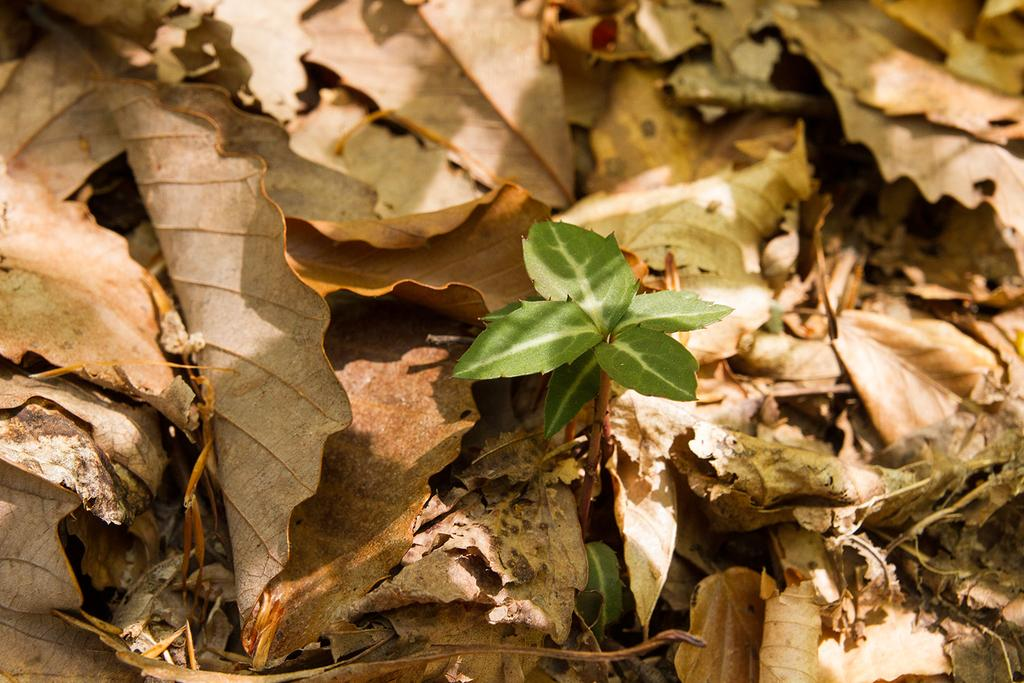What type of leaves can be seen in the image? There are green leaves and dry leaves in the image. How many dimes does the boy have in his pocket in the image? There is no boy or dimes present in the image; it only features green and dry leaves. 